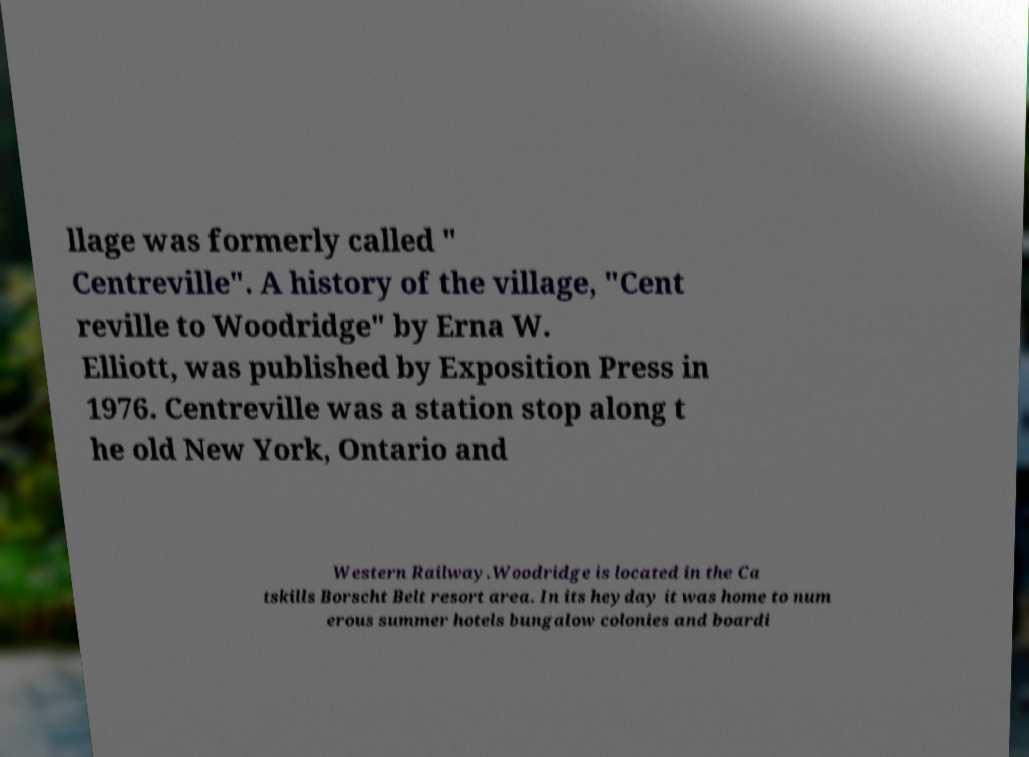There's text embedded in this image that I need extracted. Can you transcribe it verbatim? llage was formerly called " Centreville". A history of the village, "Cent reville to Woodridge" by Erna W. Elliott, was published by Exposition Press in 1976. Centreville was a station stop along t he old New York, Ontario and Western Railway.Woodridge is located in the Ca tskills Borscht Belt resort area. In its heyday it was home to num erous summer hotels bungalow colonies and boardi 